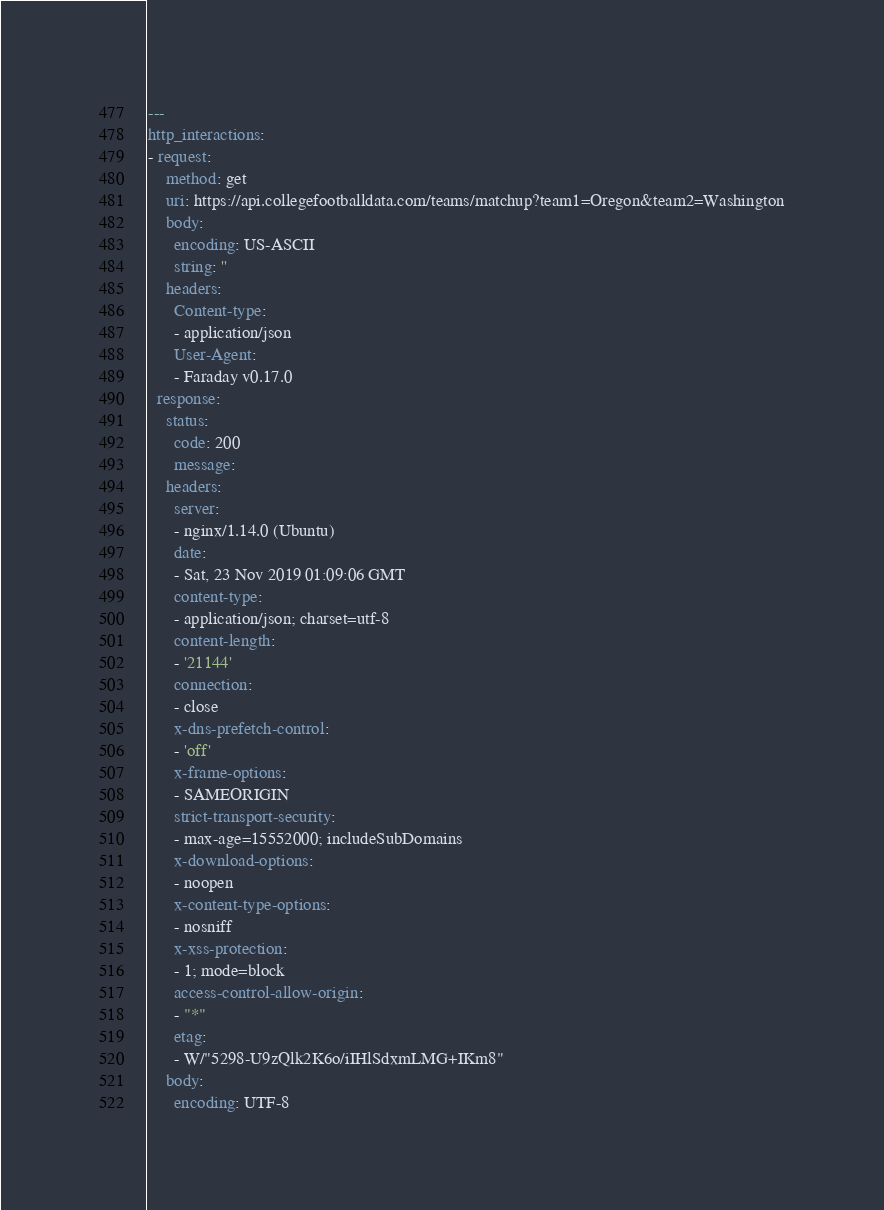<code> <loc_0><loc_0><loc_500><loc_500><_YAML_>---
http_interactions:
- request:
    method: get
    uri: https://api.collegefootballdata.com/teams/matchup?team1=Oregon&team2=Washington
    body:
      encoding: US-ASCII
      string: ''
    headers:
      Content-type:
      - application/json
      User-Agent:
      - Faraday v0.17.0
  response:
    status:
      code: 200
      message: 
    headers:
      server:
      - nginx/1.14.0 (Ubuntu)
      date:
      - Sat, 23 Nov 2019 01:09:06 GMT
      content-type:
      - application/json; charset=utf-8
      content-length:
      - '21144'
      connection:
      - close
      x-dns-prefetch-control:
      - 'off'
      x-frame-options:
      - SAMEORIGIN
      strict-transport-security:
      - max-age=15552000; includeSubDomains
      x-download-options:
      - noopen
      x-content-type-options:
      - nosniff
      x-xss-protection:
      - 1; mode=block
      access-control-allow-origin:
      - "*"
      etag:
      - W/"5298-U9zQlk2K6o/iIHlSdxmLMG+IKm8"
    body:
      encoding: UTF-8</code> 